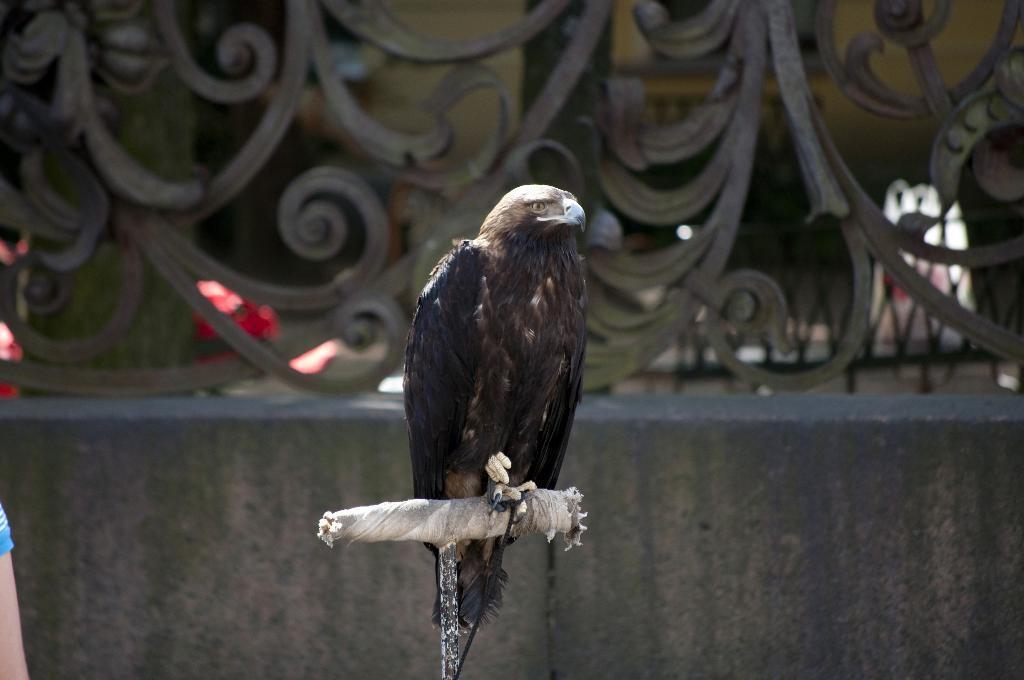Could you give a brief overview of what you see in this image? In this picture I can observe a bird which is in black color. It is looking like an eagle. In the background I can observe a railing. 